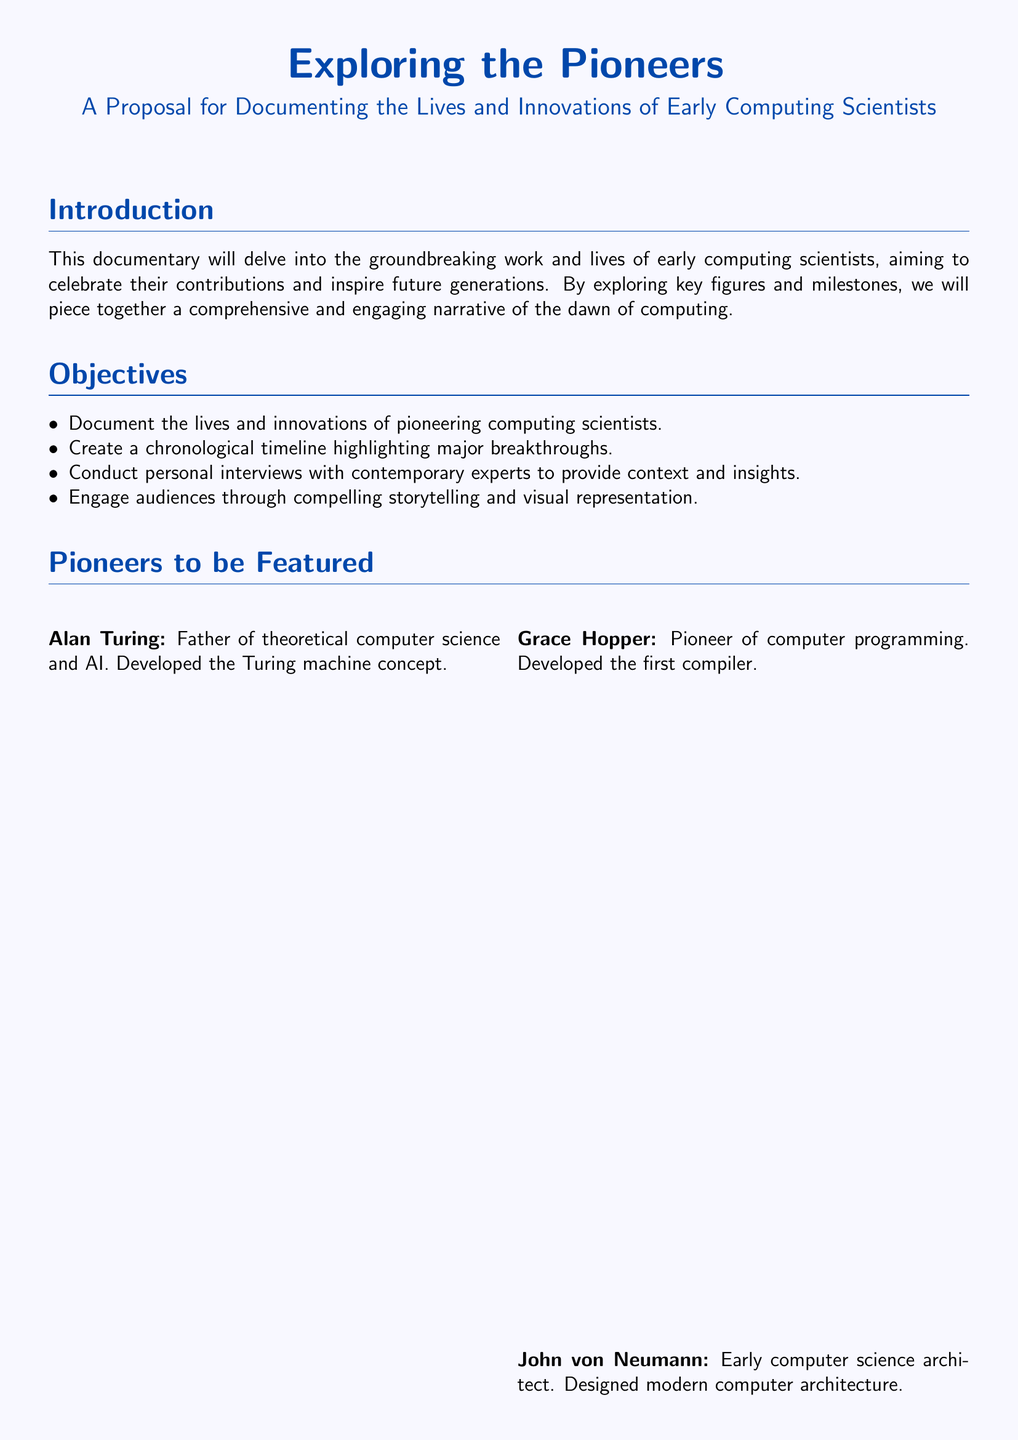what is the title of the proposal? The title of the proposal is stated at the beginning of the document.
Answer: Exploring the Pioneers who is considered the father of theoretical computer science? This information is found in the section about pioneers.
Answer: Alan Turing what year was the Analytical Engine designed? The year is included in the timeline of major breakthroughs.
Answer: 1837 which programming language was developed in 1959? The language developed in that year is specified in the timeline.
Answer: COBOL who is Vint Cerf? His role is noted in the section about interviews with contemporary experts.
Answer: Chief Internet Evangelist, Google what stage follows pre-production in the production plan? The order of the stages is outlined in the production plan section.
Answer: Production how many pioneers are listed in the document? The number of pioneers can be counted from the corresponding section.
Answer: Four what was one of the contributions of Grace Hopper? This information is found in her description in the pioneers section.
Answer: Developed the first compiler what is a key goal of the documentary? The objectives of the documentary include specific goals mentioned in the document.
Answer: Inspire future generations 